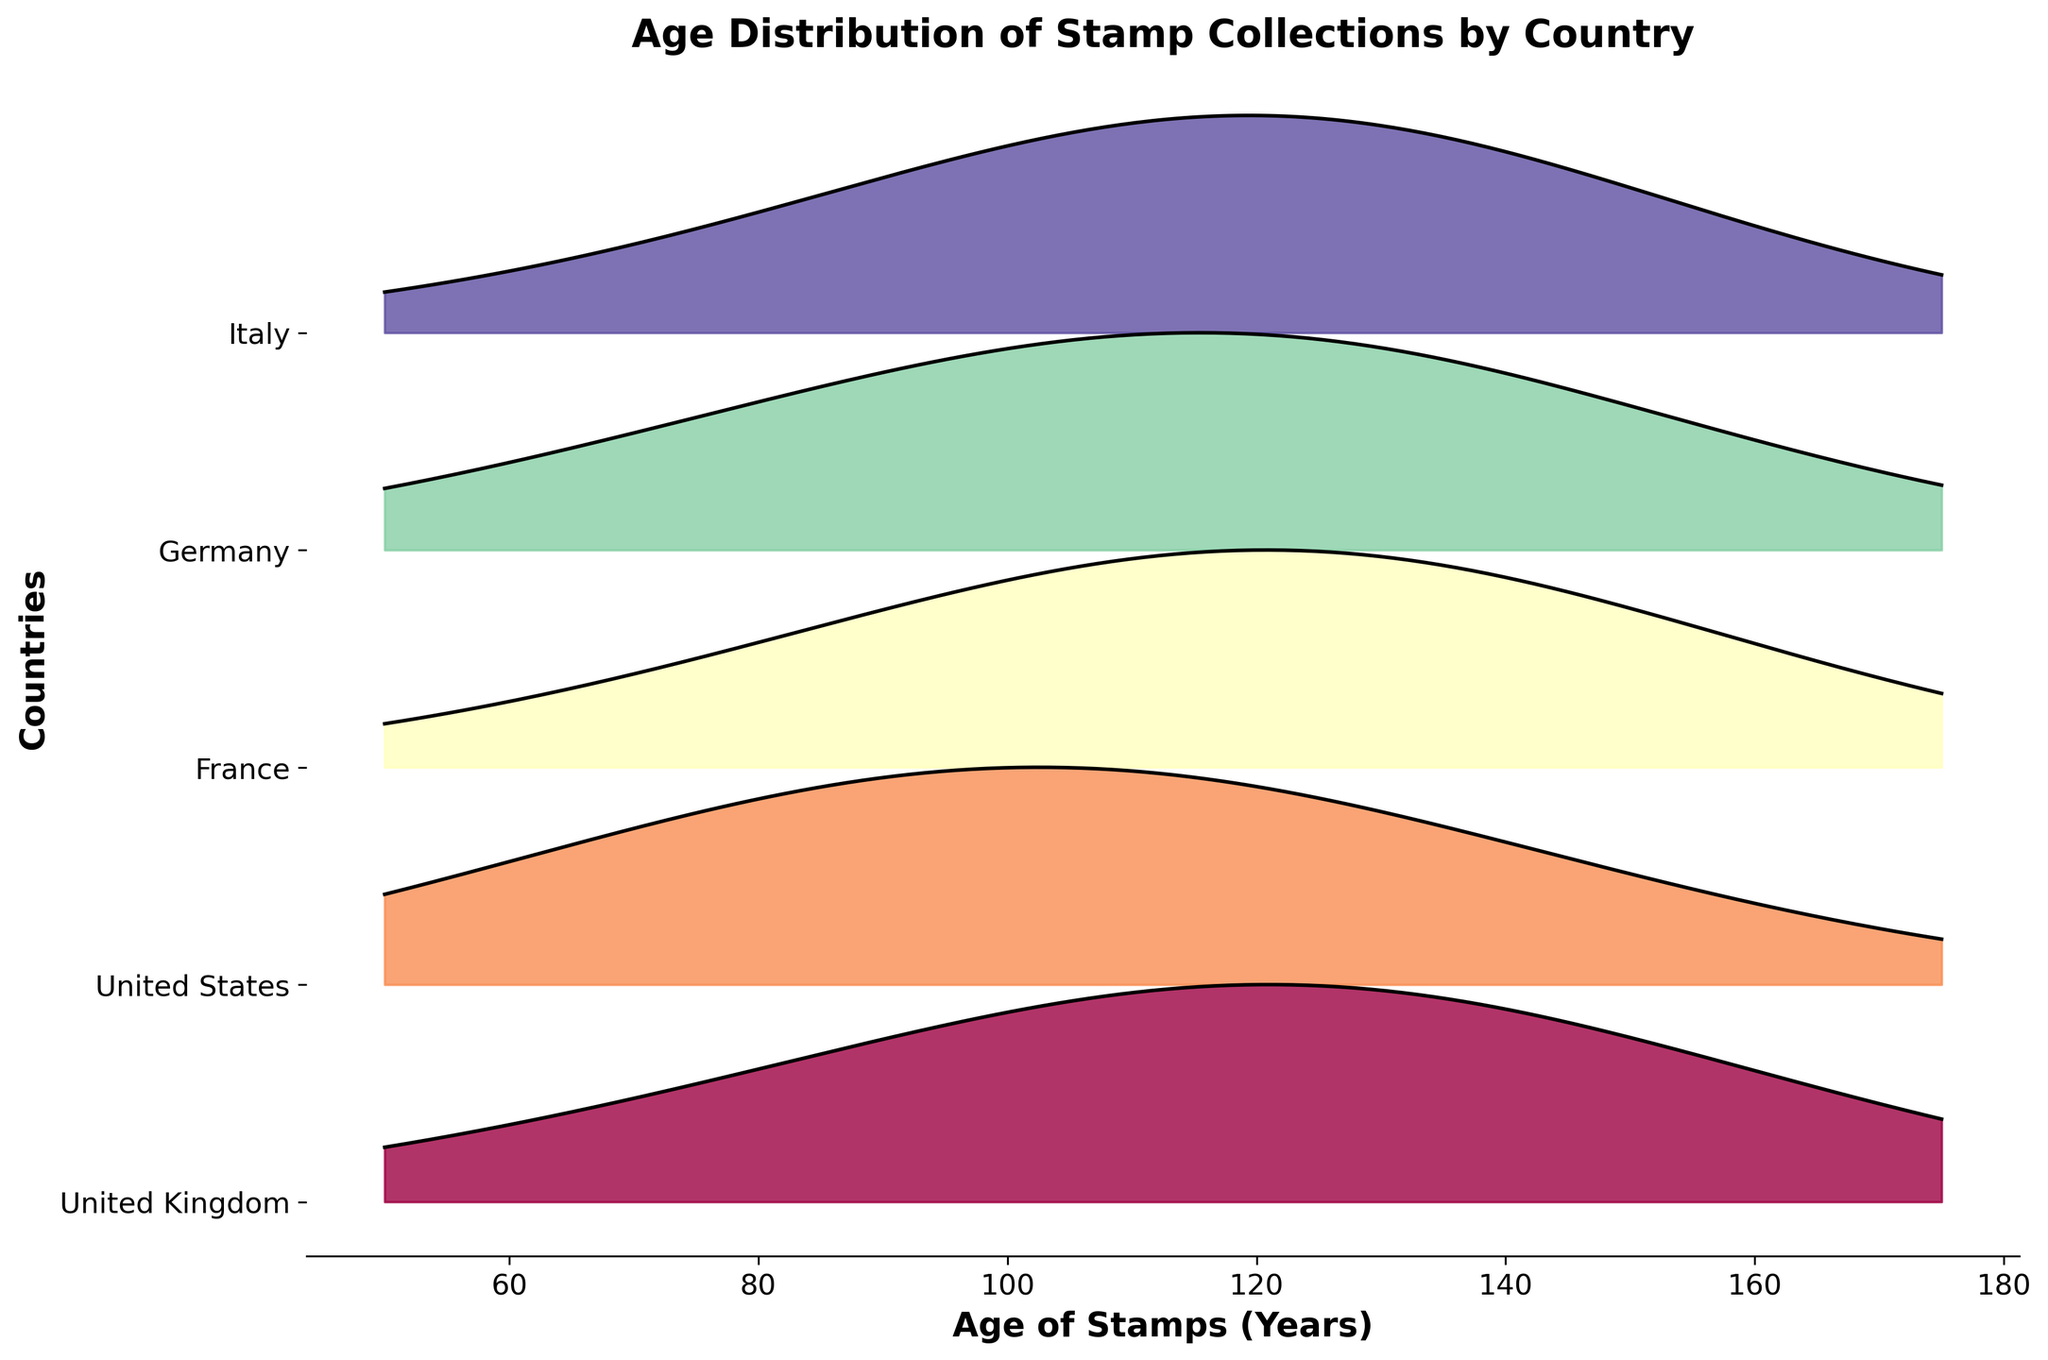What's the title of the figure? The title of the figure is displayed at the top and is written in a larger font size.
Answer: Age Distribution of Stamp Collections by Country What are the age ranges shown for the stamps? The x-axis shows the age range, which includes labels from 50 to 175 years.
Answer: 50 to 175 years Which country has the highest density peak for stamps aged 125 years? By looking at the highest point on the y-axis densitiy values for the 125-year-old stamps, Germany's curve peaks the highest.
Answer: Germany Which country has the overall broadest distribution of stamp ages? The country with the overall broadest distribution has the most spread-out or wide density curve. Compared to the others, the United Kingdom shows a wide range from 50 to 175 years.
Answer: United Kingdom How does the age distribution of French stamps compare to Italian stamps? By comparing the curves for France and Italy, we see that French stamps have a peak at 125 years, while Italian stamps have a similar peak at 125 years, but the density decreases more significantly afterward for Italian stamps.
Answer: France and Italy have similar peaks at 125 years, but Italy's density drops more sharply after 125 years At what age range do United States stamps have the highest density? Looking at the curves for United States stamps, their highest peak is at 100 years.
Answer: 100 years For which countries do stamps have a density at 50 years? The ridgeline plot reveals that both United Kingdom and United States have some density at 50 years, although it is not the highest density for either.
Answer: United Kingdom and United States Which country has the lowest density for stamps aged 175 years? By observing the curves, the United States shows the lowest density at 175 years when compared to other countries.
Answer: United States What is the density value for United Kingdom stamps aged 100 years? Observing the curve for the United Kingdom and following it to where it crosses the 100-year mark, the density value is noted as approximately 0.10.
Answer: 0.10 How does the density of German stamps at 150 years compare to French stamps at the same age? Comparing the height of the curves at the 150-year mark, German stamps have a higher peak density than French stamps.
Answer: Germany's peak is higher than France's at 150 years 